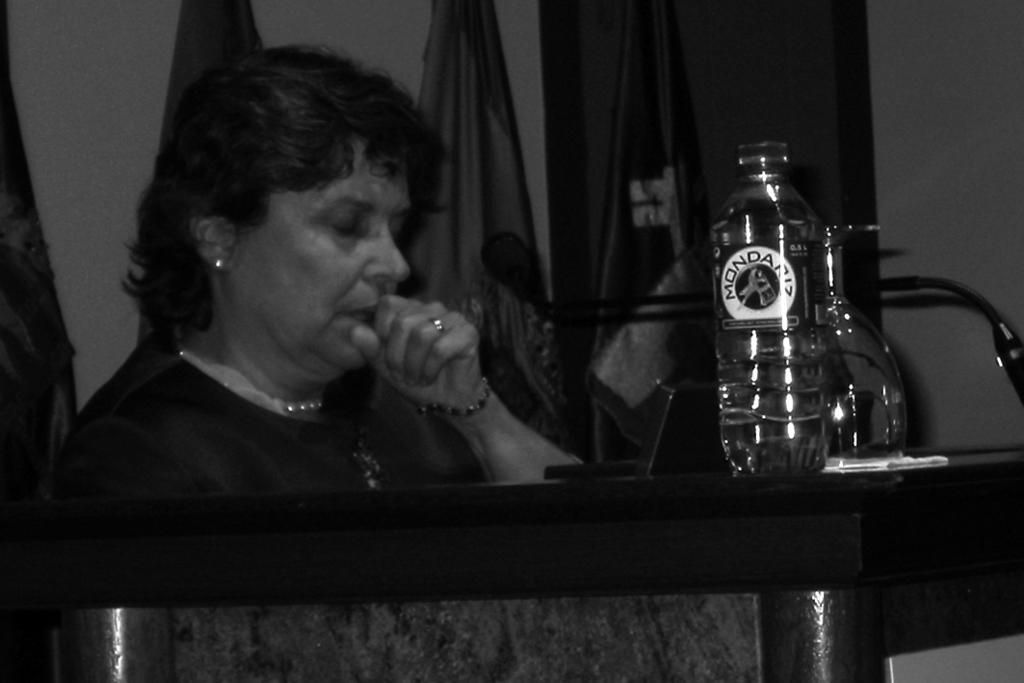Who is present in the image? There is a woman in the image. Where is the woman located? The woman is at a table. What can be seen on the table? There are items on the table. What is visible in the background of the image? There are flags and a wall visible in the background of the image. What type of bed is the carpenter working on in the image? There is no carpenter or bed present in the image. Is the bat flying around the woman in the image? There is no bat present in the image. 